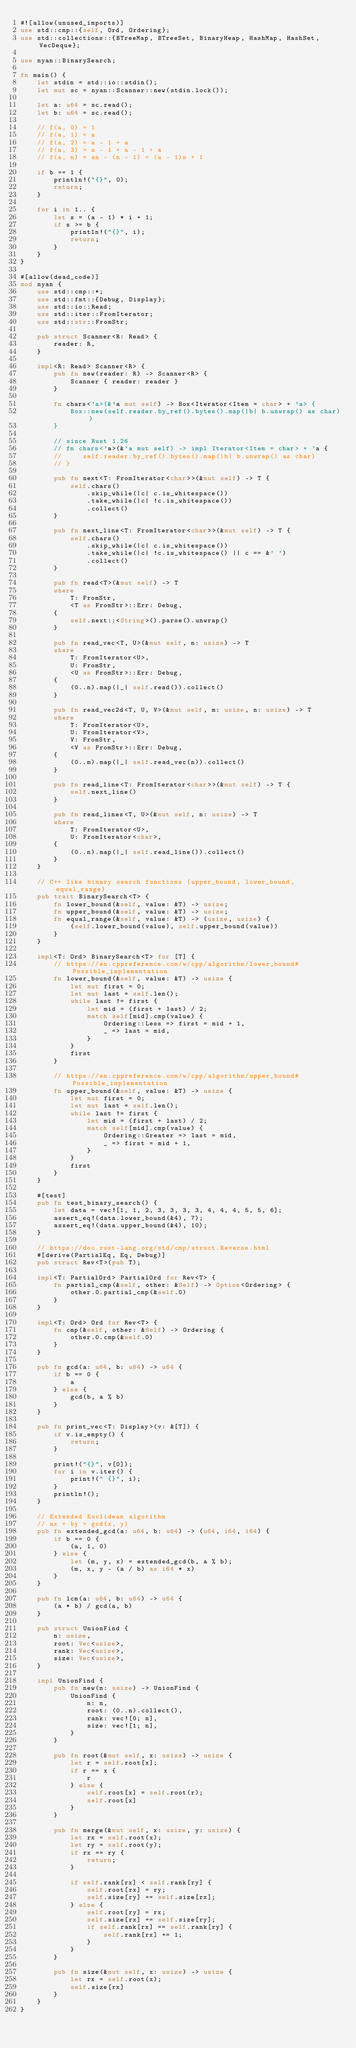Convert code to text. <code><loc_0><loc_0><loc_500><loc_500><_Rust_>#![allow(unused_imports)]
use std::cmp::{self, Ord, Ordering};
use std::collections::{BTreeMap, BTreeSet, BinaryHeap, HashMap, HashSet, VecDeque};

use nyan::BinarySearch;

fn main() {
    let stdin = std::io::stdin();
    let mut sc = nyan::Scanner::new(stdin.lock());

    let a: u64 = sc.read();
    let b: u64 = sc.read();

    // f(a, 0) = 1
    // f(a, 1) = a
    // f(a, 2) = a - 1 + a
    // f(a, 3) = a - 1 + a - 1 + a
    // f(a, n) = an - (n - 1) = (a - 1)n + 1

    if b == 1 {
        println!("{}", 0);
        return;
    }

    for i in 1.. {
        let s = (a - 1) * i + 1;
        if s >= b {
            println!("{}", i);
            return;
        }
    }
}

#[allow(dead_code)]
mod nyan {
    use std::cmp::*;
    use std::fmt::{Debug, Display};
    use std::io::Read;
    use std::iter::FromIterator;
    use std::str::FromStr;

    pub struct Scanner<R: Read> {
        reader: R,
    }

    impl<R: Read> Scanner<R> {
        pub fn new(reader: R) -> Scanner<R> {
            Scanner { reader: reader }
        }

        fn chars<'a>(&'a mut self) -> Box<Iterator<Item = char> + 'a> {
            Box::new(self.reader.by_ref().bytes().map(|b| b.unwrap() as char))
        }

        // since Rust 1.26
        // fn chars<'a>(&'a mut self) -> impl Iterator<Item = char> + 'a {
        //     self.reader.by_ref().bytes().map(|b| b.unwrap() as char)
        // }

        pub fn next<T: FromIterator<char>>(&mut self) -> T {
            self.chars()
                .skip_while(|c| c.is_whitespace())
                .take_while(|c| !c.is_whitespace())
                .collect()
        }

        pub fn next_line<T: FromIterator<char>>(&mut self) -> T {
            self.chars()
                .skip_while(|c| c.is_whitespace())
                .take_while(|c| !c.is_whitespace() || c == &' ')
                .collect()
        }

        pub fn read<T>(&mut self) -> T
        where
            T: FromStr,
            <T as FromStr>::Err: Debug,
        {
            self.next::<String>().parse().unwrap()
        }

        pub fn read_vec<T, U>(&mut self, n: usize) -> T
        where
            T: FromIterator<U>,
            U: FromStr,
            <U as FromStr>::Err: Debug,
        {
            (0..n).map(|_| self.read()).collect()
        }

        pub fn read_vec2d<T, U, V>(&mut self, m: usize, n: usize) -> T
        where
            T: FromIterator<U>,
            U: FromIterator<V>,
            V: FromStr,
            <V as FromStr>::Err: Debug,
        {
            (0..m).map(|_| self.read_vec(n)).collect()
        }

        pub fn read_line<T: FromIterator<char>>(&mut self) -> T {
            self.next_line()
        }

        pub fn read_lines<T, U>(&mut self, n: usize) -> T
        where
            T: FromIterator<U>,
            U: FromIterator<char>,
        {
            (0..n).map(|_| self.read_line()).collect()
        }
    }

    // C++ like binary search functions (upper_bound, lower_bound, equal_range)
    pub trait BinarySearch<T> {
        fn lower_bound(&self, value: &T) -> usize;
        fn upper_bound(&self, value: &T) -> usize;
        fn equal_range(&self, value: &T) -> (usize, usize) {
            (self.lower_bound(value), self.upper_bound(value))
        }
    }

    impl<T: Ord> BinarySearch<T> for [T] {
        // https://en.cppreference.com/w/cpp/algorithm/lower_bound#Possible_implementation
        fn lower_bound(&self, value: &T) -> usize {
            let mut first = 0;
            let mut last = self.len();
            while last != first {
                let mid = (first + last) / 2;
                match self[mid].cmp(value) {
                    Ordering::Less => first = mid + 1,
                    _ => last = mid,
                }
            }
            first
        }

        // https://en.cppreference.com/w/cpp/algorithm/upper_bound#Possible_implementation
        fn upper_bound(&self, value: &T) -> usize {
            let mut first = 0;
            let mut last = self.len();
            while last != first {
                let mid = (first + last) / 2;
                match self[mid].cmp(value) {
                    Ordering::Greater => last = mid,
                    _ => first = mid + 1,
                }
            }
            first
        }
    }

    #[test]
    pub fn test_binary_search() {
        let data = vec![1, 1, 2, 3, 3, 3, 3, 4, 4, 4, 5, 5, 6];
        assert_eq!(data.lower_bound(&4), 7);
        assert_eq!(data.upper_bound(&4), 10);
    }

    // https://doc.rust-lang.org/std/cmp/struct.Reverse.html
    #[derive(PartialEq, Eq, Debug)]
    pub struct Rev<T>(pub T);

    impl<T: PartialOrd> PartialOrd for Rev<T> {
        fn partial_cmp(&self, other: &Self) -> Option<Ordering> {
            other.0.partial_cmp(&self.0)
        }
    }

    impl<T: Ord> Ord for Rev<T> {
        fn cmp(&self, other: &Self) -> Ordering {
            other.0.cmp(&self.0)
        }
    }

    pub fn gcd(a: u64, b: u64) -> u64 {
        if b == 0 {
            a
        } else {
            gcd(b, a % b)
        }
    }

    pub fn print_vec<T: Display>(v: &[T]) {
        if v.is_empty() {
            return;
        }

        print!("{}", v[0]);
        for i in v.iter() {
            print!(" {}", i);
        }
        println!();
    }

    // Extended Euclidean algorithm
    // ax + by = gcd(x, y)
    pub fn extended_gcd(a: u64, b: u64) -> (u64, i64, i64) {
        if b == 0 {
            (a, 1, 0)
        } else {
            let (m, y, x) = extended_gcd(b, a % b);
            (m, x, y - (a / b) as i64 * x)
        }
    }

    pub fn lcm(a: u64, b: u64) -> u64 {
        (a * b) / gcd(a, b)
    }

    pub struct UnionFind {
        n: usize,
        root: Vec<usize>,
        rank: Vec<usize>,
        size: Vec<usize>,
    }

    impl UnionFind {
        pub fn new(n: usize) -> UnionFind {
            UnionFind {
                n: n,
                root: (0..n).collect(),
                rank: vec![0; n],
                size: vec![1; n],
            }
        }

        pub fn root(&mut self, x: usize) -> usize {
            let r = self.root[x];
            if r == x {
                r
            } else {
                self.root[x] = self.root(r);
                self.root[x]
            }
        }

        pub fn merge(&mut self, x: usize, y: usize) {
            let rx = self.root(x);
            let ry = self.root(y);
            if rx == ry {
                return;
            }

            if self.rank[rx] < self.rank[ry] {
                self.root[rx] = ry;
                self.size[ry] += self.size[rx];
            } else {
                self.root[ry] = rx;
                self.size[rx] += self.size[ry];
                if self.rank[rx] == self.rank[ry] {
                    self.rank[rx] += 1;
                }
            }
        }

        pub fn size(&mut self, x: usize) -> usize {
            let rx = self.root(x);
            self.size[rx]
        }
    }
}
</code> 